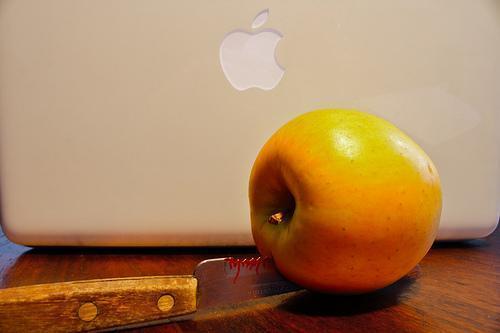How many apples are there?
Give a very brief answer. 1. 